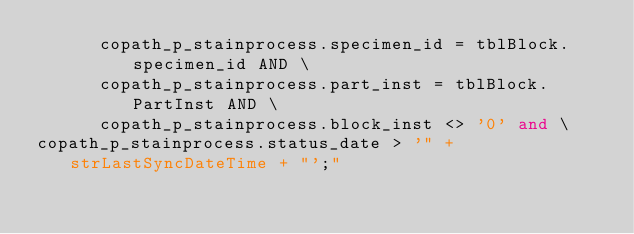Convert code to text. <code><loc_0><loc_0><loc_500><loc_500><_SQL_>		  copath_p_stainprocess.specimen_id = tblBlock.specimen_id AND \
		  copath_p_stainprocess.part_inst = tblBlock.PartInst AND \
			copath_p_stainprocess.block_inst <> '0' and \
copath_p_stainprocess.status_date > '" + strLastSyncDateTime + "';"
</code> 